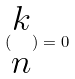Convert formula to latex. <formula><loc_0><loc_0><loc_500><loc_500>( \begin{matrix} k \\ n \end{matrix} ) = 0</formula> 